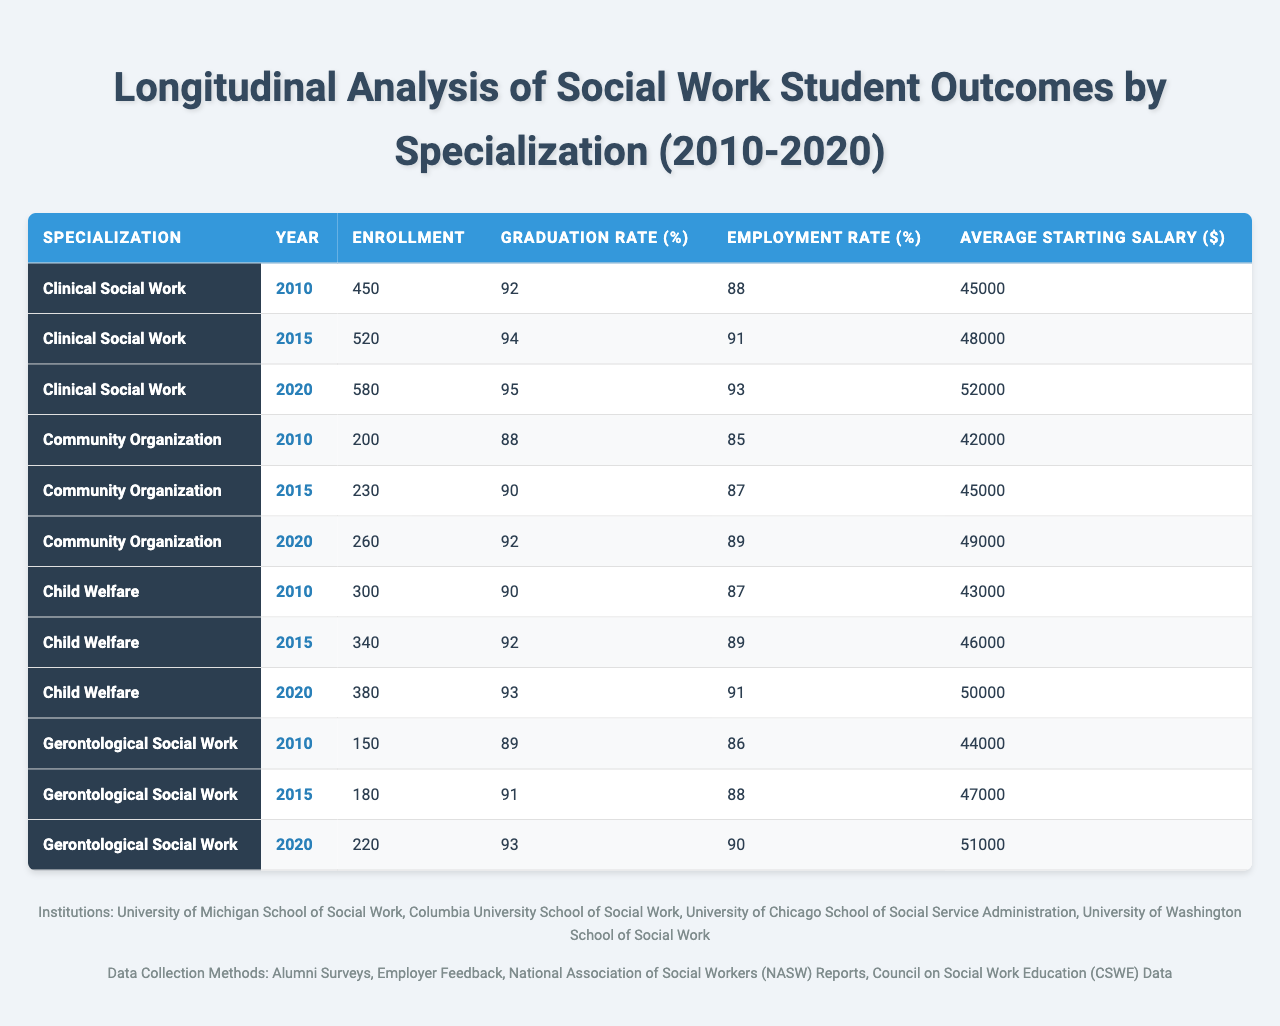What was the enrollment for Clinical Social Work in 2015? The table shows the enrollment for each specialization in different years. For Clinical Social Work in 2015, the table indicates an enrollment of 520 students.
Answer: 520 What is the graduation rate for Community Organization in 2020? Referring to the table, the graduation rate for Community Organization in the year 2020 is listed as 92%.
Answer: 92% Which specialization had the highest average starting salary in 2020? From the table, we look at the average starting salaries for each specialization in 2020: Clinical Social Work ($52,000), Community Organization ($49,000), Child Welfare ($50,000), and Gerontological Social Work ($51,000). The highest is Clinical Social Work at $52,000.
Answer: Clinical Social Work What is the difference in graduation rates between Clinical Social Work in 2010 and Child Welfare in 2020? The graduation rate for Clinical Social Work in 2010 is 92%, and for Child Welfare in 2020 it is 93%. The difference is calculated as 93% - 92% = 1%.
Answer: 1% What was the average starting salary across all specializations in 2020? The average starting salaries in 2020 are: Clinical Social Work ($52,000), Community Organization ($49,000), Child Welfare ($50,000), and Gerontological Social Work ($51,000). We calculate the total as $52,000 + $49,000 + $50,000 + $51,000 = $202,000. Dividing by 4 gives us an average of $202,000 / 4 = $50,500.
Answer: $50,500 In which year did Gerontological Social Work have the lowest enrollment? Looking at the table, the enrollment numbers for Gerontological Social Work are 150 in 2010, 180 in 2015, and 220 in 2020. The lowest enrollment is in 2010 with 150 students.
Answer: 2010 Did the employment rate for Child Welfare improve from 2015 to 2020? The employment rate for Child Welfare was 89% in 2015 and increased to 91% in 2020. Therefore, we can confirm that the employment rate did improve during this period.
Answer: Yes What is the percentage increase in enrollment for Community Organization from 2010 to 2020? The enrollment for Community Organization was 200 in 2010 and 260 in 2020. The percentage increase is calculated as ((260 - 200) / 200) * 100% = 30%.
Answer: 30% Which specialization had the highest employment rate in 2015? Evaluating the employment rates for 2015: Clinical Social Work (91%), Community Organization (87%), Child Welfare (89%), and Gerontological Social Work (88%). The highest employment rate in 2015 was for Clinical Social Work at 91%.
Answer: Clinical Social Work What was the average graduation rate over the years for Gerontological Social Work? The graduation rates for Gerontological Social Work are 89% in 2010, 91% in 2015, and 93% in 2020. Summing these values gives 89% + 91% + 93% = 273%, and dividing by 3 results in an average of 273% / 3 = 91%.
Answer: 91% Was the average starting salary for Clinical Social Work higher than that of Gerontological Social Work in 2015? In the year 2015, Clinical Social Work had an average starting salary of $48,000, while Gerontological Social Work had $47,000. Since $48,000 > $47,000, Clinical Social Work had a higher average.
Answer: Yes 